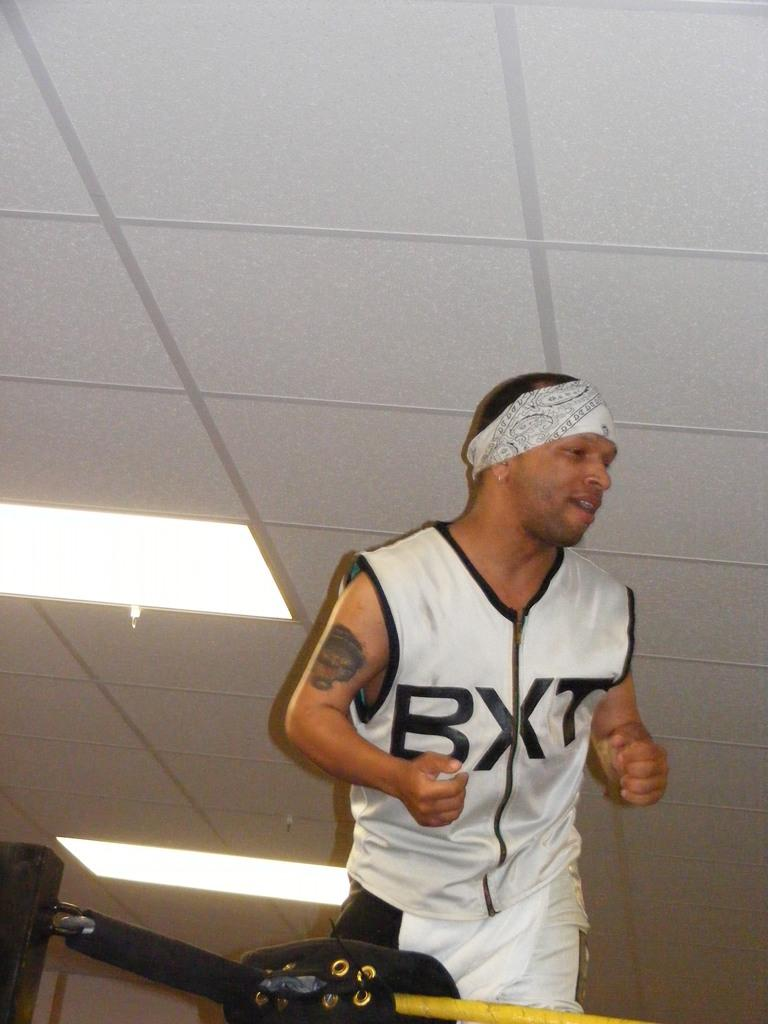Provide a one-sentence caption for the provided image. Man with bandana and althetic jersey displaying BXT on front. 